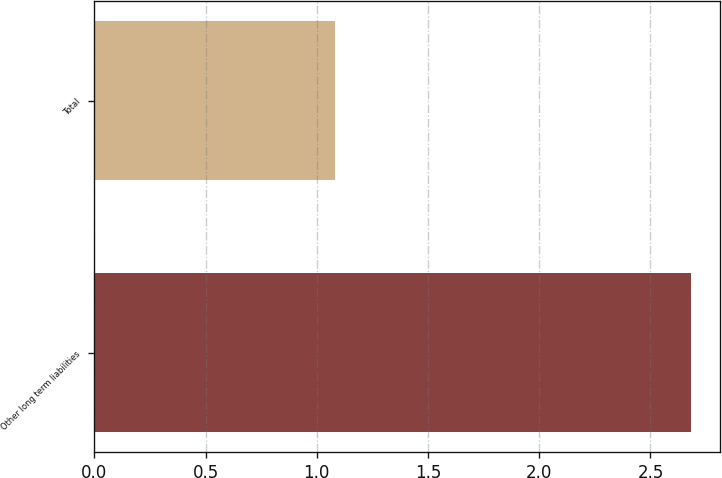Convert chart to OTSL. <chart><loc_0><loc_0><loc_500><loc_500><bar_chart><fcel>Other long term liabilities<fcel>Total<nl><fcel>2.68<fcel>1.08<nl></chart> 